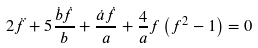<formula> <loc_0><loc_0><loc_500><loc_500>2 \ddot { f } + 5 \frac { \dot { b } \dot { f } } { b } + \frac { \dot { a } \dot { f } } { a } + \frac { 4 } { a } f \left ( f ^ { 2 } - 1 \right ) = 0</formula> 